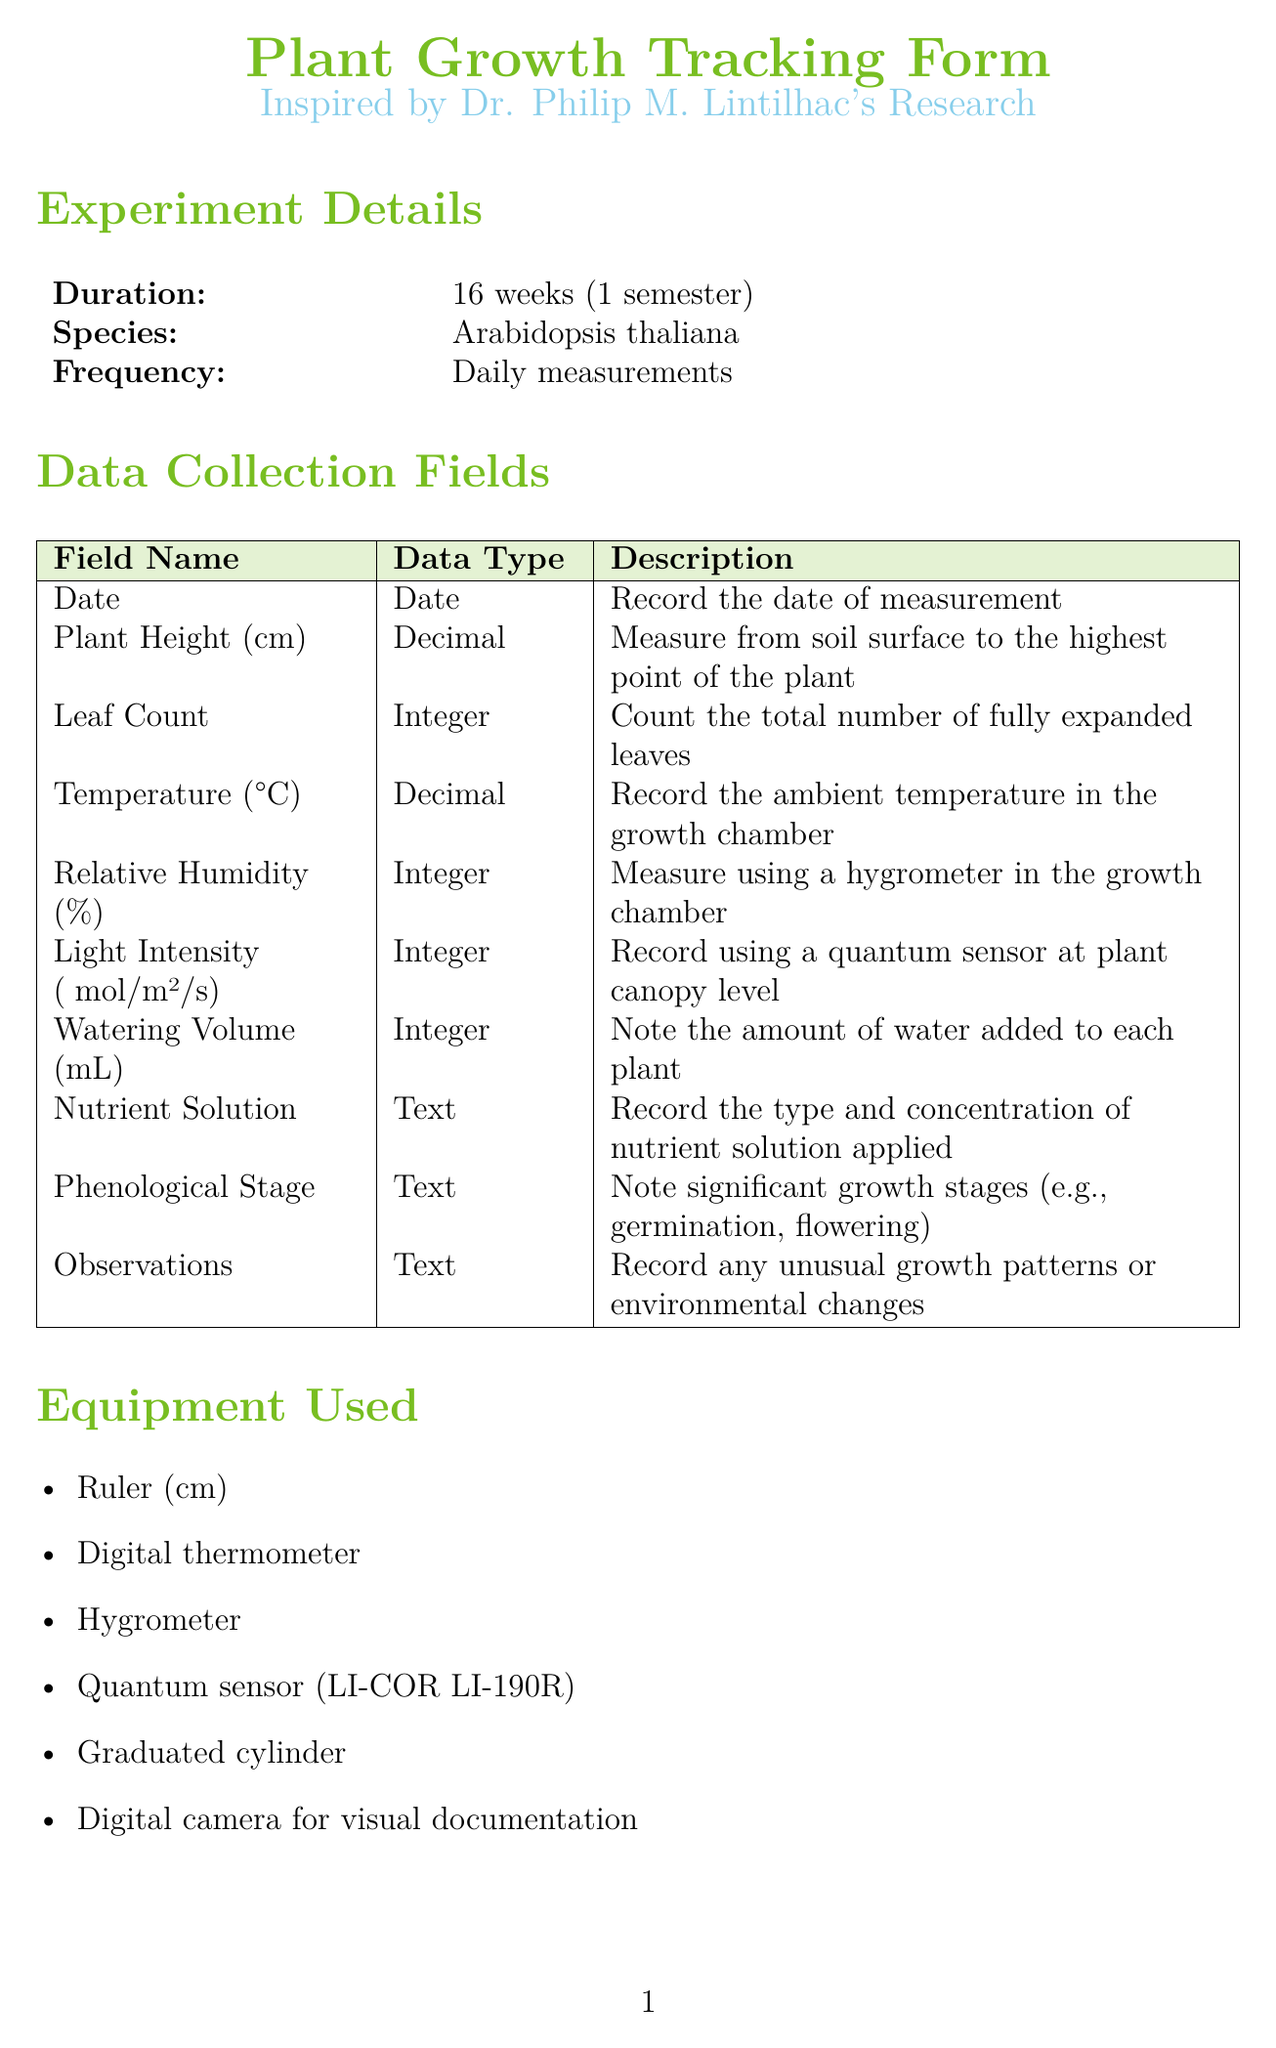What is the duration of the experiment? The duration of the experiment is specified in the document, highlighting the length of time for data collection.
Answer: 16 weeks What species is being studied? The document identifies the specific plant species used in the experiment, relevant to the growth tracking.
Answer: Arabidopsis thaliana How frequently are measurements taken? The document states the measurement frequency, indicating how often data is collected throughout the experiment.
Answer: Daily What equipment is used to measure temperature? The document lists the tools required for the experiment, including those for environmental measurements.
Answer: Digital thermometer How many replicates are there in the experimental setup? The number of replicates is included in the experimental setup section, indicating the number of test subjects analyzed.
Answer: 5 What type of statistical analysis is suggested for growth trends? The document provides guidance on data analysis methods, specifying a particular statistical approach.
Answer: Repeated measures ANOVA What is the light cycle defined in the experimental setup? The light cycle is mentioned in the document, detailing the conditions under which the plants are grown.
Answer: 16 hours light / 8 hours dark What is the substrate mixture used for planting? The type of substrate used is described in the experimental setup, important for understanding plant growth conditions.
Answer: 1:1 mixture of peat moss and vermiculite Which software is recommended for data visualization? The document mentions a specific software tool for analyzing and visualizing data, relevant for the analysis section.
Answer: R statistical software 